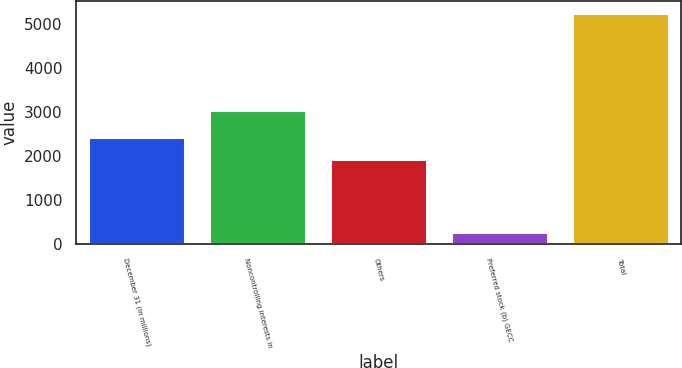<chart> <loc_0><loc_0><loc_500><loc_500><bar_chart><fcel>December 31 (In millions)<fcel>Noncontrolling interests in<fcel>Others<fcel>Preferred stock (b) GECC<fcel>Total<nl><fcel>2443.5<fcel>3040<fcel>1945<fcel>277<fcel>5262<nl></chart> 